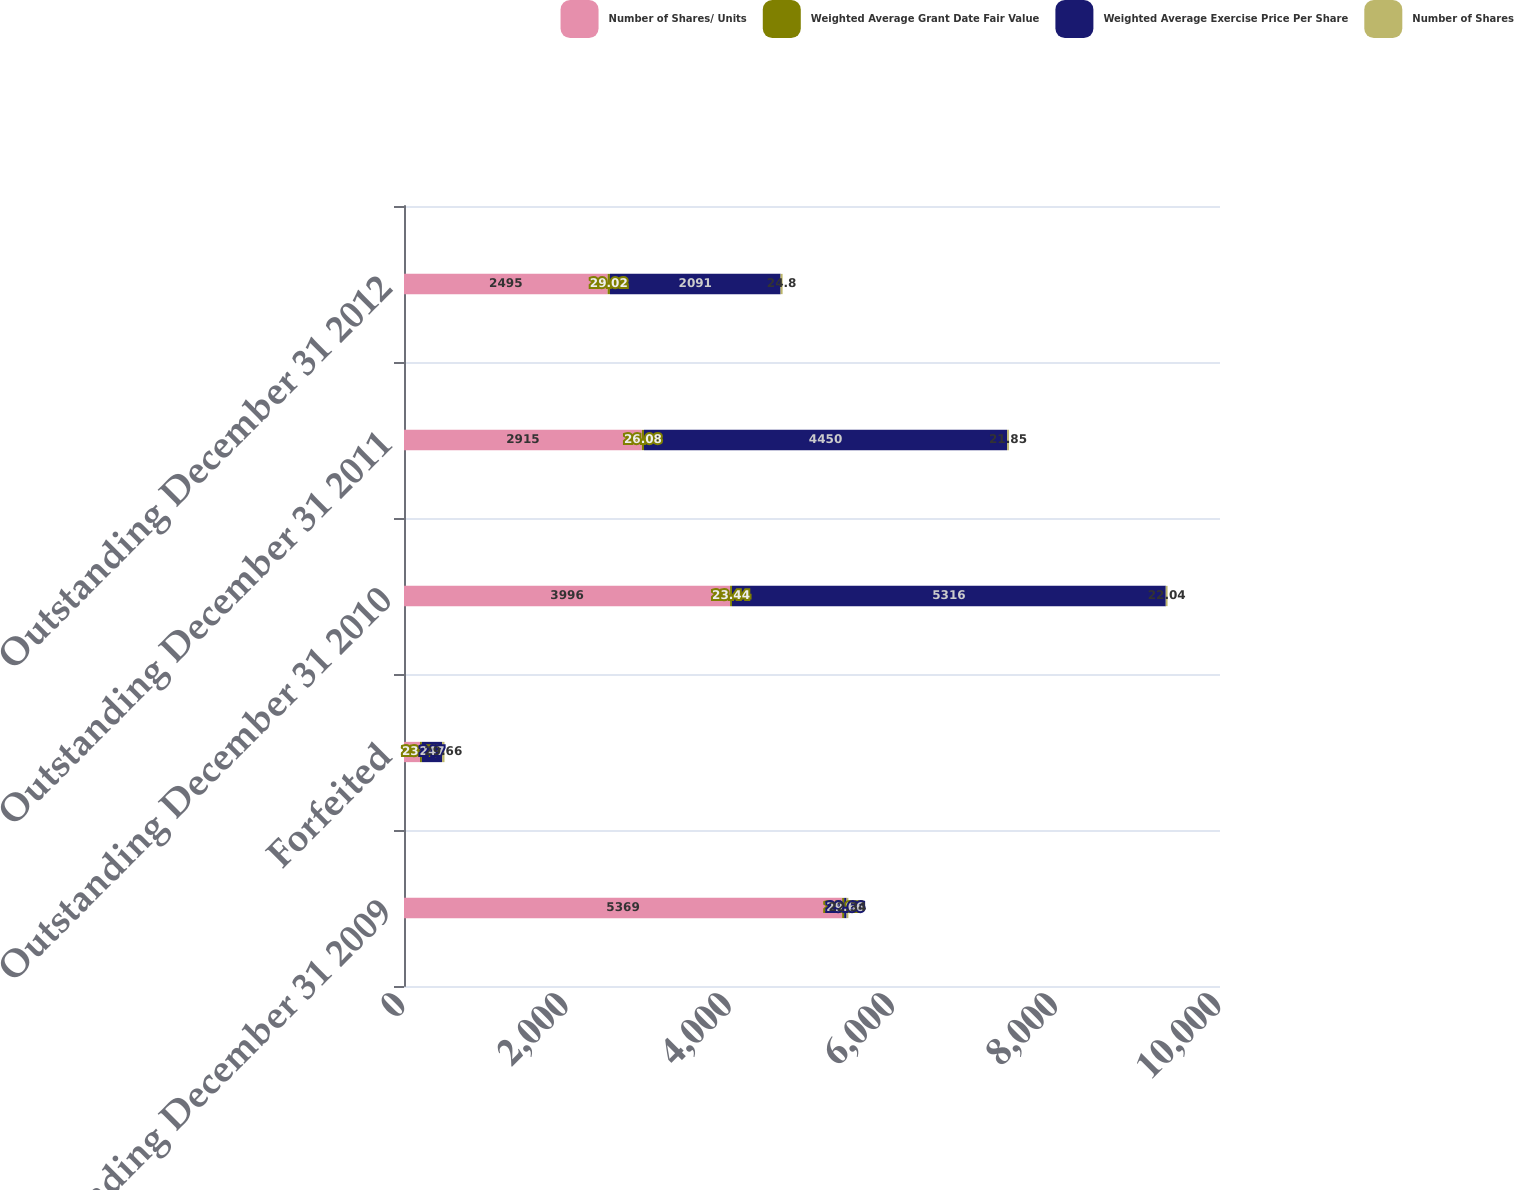Convert chart. <chart><loc_0><loc_0><loc_500><loc_500><stacked_bar_chart><ecel><fcel>Outstanding December 31 2009<fcel>Forfeited<fcel>Outstanding December 31 2010<fcel>Outstanding December 31 2011<fcel>Outstanding December 31 2012<nl><fcel>Number of Shares/ Units<fcel>5369<fcel>196<fcel>3996<fcel>2915<fcel>2495<nl><fcel>Weighted Average Grant Date Fair Value<fcel>24.87<fcel>23.48<fcel>23.44<fcel>26.08<fcel>29.02<nl><fcel>Weighted Average Exercise Price Per Share<fcel>29.66<fcel>247<fcel>5316<fcel>4450<fcel>2091<nl><fcel>Number of Shares<fcel>22.34<fcel>29.66<fcel>22.04<fcel>21.85<fcel>24.8<nl></chart> 